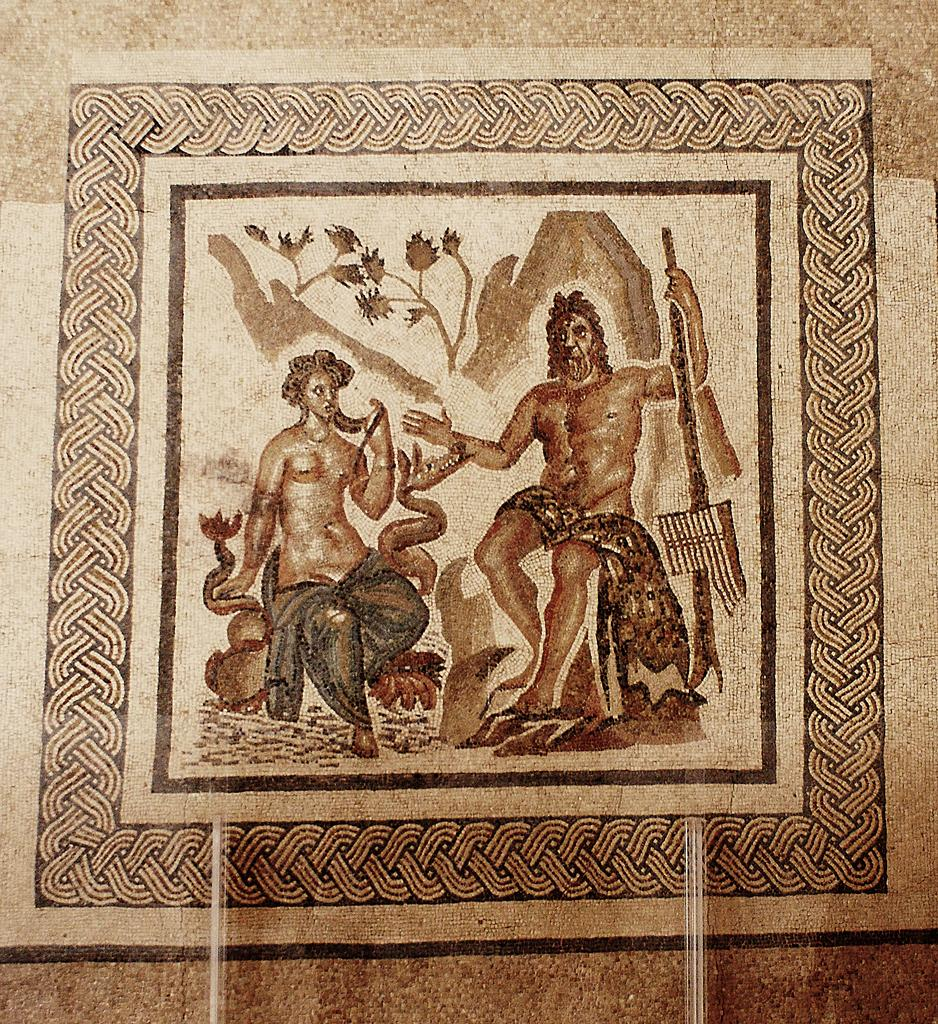What is the main subject of the image? There is a painting in the image. Are there any living beings in the image? Yes, there are people in the image. What type of natural elements can be seen in the image? Leaves are present in the image. Can you describe any other objects in the image? There are unspecified objects in the image. What type of pear is being used as a lamp in the image? There is no pear or lamp present in the image. 